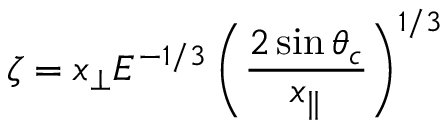<formula> <loc_0><loc_0><loc_500><loc_500>\zeta = x _ { \perp } E ^ { - 1 / 3 } \left ( \frac { 2 \sin \theta _ { c } } { x _ { \| } } \right ) ^ { 1 / 3 }</formula> 